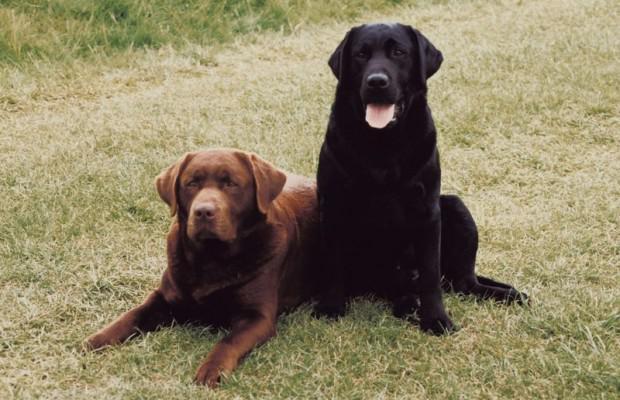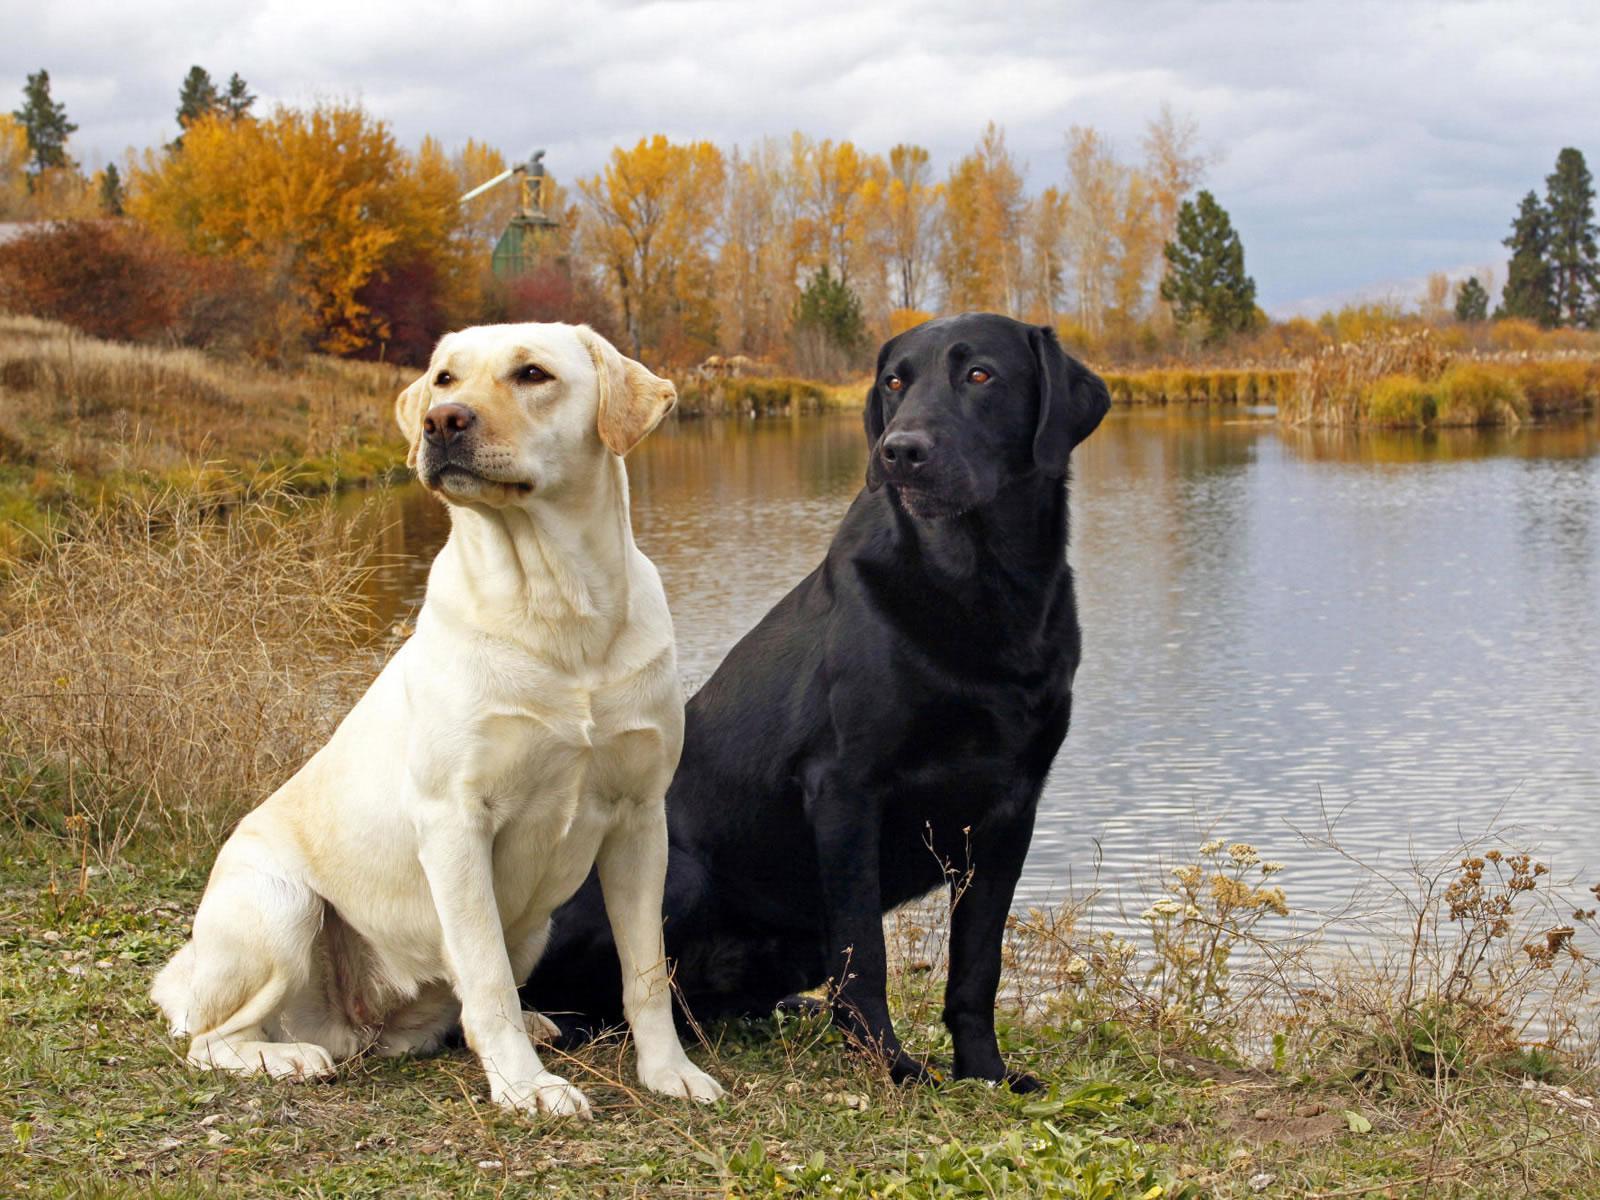The first image is the image on the left, the second image is the image on the right. For the images displayed, is the sentence "There are four dogs in total." factually correct? Answer yes or no. Yes. The first image is the image on the left, the second image is the image on the right. Analyze the images presented: Is the assertion "The right image contains two dogs." valid? Answer yes or no. Yes. 